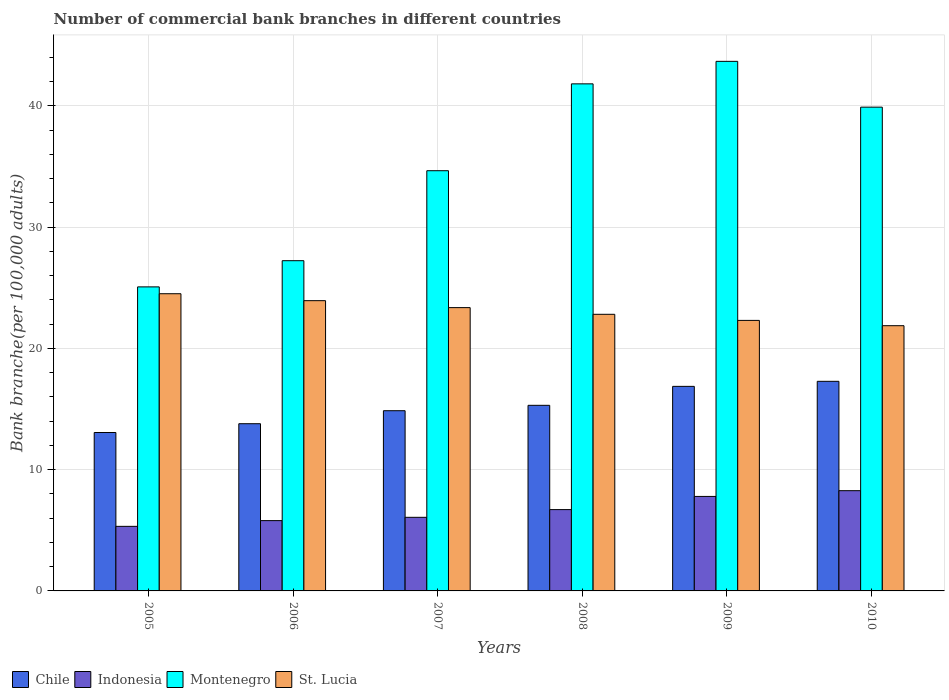How many different coloured bars are there?
Your response must be concise. 4. How many groups of bars are there?
Keep it short and to the point. 6. Are the number of bars on each tick of the X-axis equal?
Ensure brevity in your answer.  Yes. How many bars are there on the 3rd tick from the right?
Ensure brevity in your answer.  4. In how many cases, is the number of bars for a given year not equal to the number of legend labels?
Ensure brevity in your answer.  0. What is the number of commercial bank branches in St. Lucia in 2005?
Make the answer very short. 24.51. Across all years, what is the maximum number of commercial bank branches in Chile?
Your answer should be very brief. 17.28. Across all years, what is the minimum number of commercial bank branches in Chile?
Provide a short and direct response. 13.06. In which year was the number of commercial bank branches in St. Lucia maximum?
Provide a short and direct response. 2005. What is the total number of commercial bank branches in St. Lucia in the graph?
Ensure brevity in your answer.  138.79. What is the difference between the number of commercial bank branches in Chile in 2005 and that in 2010?
Offer a very short reply. -4.22. What is the difference between the number of commercial bank branches in Chile in 2005 and the number of commercial bank branches in Montenegro in 2009?
Provide a short and direct response. -30.61. What is the average number of commercial bank branches in Indonesia per year?
Your response must be concise. 6.66. In the year 2007, what is the difference between the number of commercial bank branches in Montenegro and number of commercial bank branches in Indonesia?
Give a very brief answer. 28.58. In how many years, is the number of commercial bank branches in Indonesia greater than 24?
Offer a very short reply. 0. What is the ratio of the number of commercial bank branches in Chile in 2005 to that in 2008?
Provide a succinct answer. 0.85. Is the difference between the number of commercial bank branches in Montenegro in 2007 and 2009 greater than the difference between the number of commercial bank branches in Indonesia in 2007 and 2009?
Provide a short and direct response. No. What is the difference between the highest and the second highest number of commercial bank branches in Montenegro?
Your response must be concise. 1.86. What is the difference between the highest and the lowest number of commercial bank branches in Indonesia?
Make the answer very short. 2.94. Is it the case that in every year, the sum of the number of commercial bank branches in Montenegro and number of commercial bank branches in Indonesia is greater than the sum of number of commercial bank branches in St. Lucia and number of commercial bank branches in Chile?
Offer a very short reply. Yes. What does the 1st bar from the right in 2009 represents?
Offer a very short reply. St. Lucia. Is it the case that in every year, the sum of the number of commercial bank branches in Indonesia and number of commercial bank branches in Chile is greater than the number of commercial bank branches in Montenegro?
Your response must be concise. No. How many bars are there?
Offer a terse response. 24. Does the graph contain any zero values?
Keep it short and to the point. No. What is the title of the graph?
Make the answer very short. Number of commercial bank branches in different countries. Does "Upper middle income" appear as one of the legend labels in the graph?
Provide a succinct answer. No. What is the label or title of the Y-axis?
Offer a very short reply. Bank branche(per 100,0 adults). What is the Bank branche(per 100,000 adults) of Chile in 2005?
Ensure brevity in your answer.  13.06. What is the Bank branche(per 100,000 adults) in Indonesia in 2005?
Provide a succinct answer. 5.32. What is the Bank branche(per 100,000 adults) in Montenegro in 2005?
Your answer should be very brief. 25.07. What is the Bank branche(per 100,000 adults) of St. Lucia in 2005?
Ensure brevity in your answer.  24.51. What is the Bank branche(per 100,000 adults) in Chile in 2006?
Your answer should be compact. 13.79. What is the Bank branche(per 100,000 adults) in Indonesia in 2006?
Give a very brief answer. 5.8. What is the Bank branche(per 100,000 adults) in Montenegro in 2006?
Your response must be concise. 27.23. What is the Bank branche(per 100,000 adults) of St. Lucia in 2006?
Provide a short and direct response. 23.93. What is the Bank branche(per 100,000 adults) of Chile in 2007?
Ensure brevity in your answer.  14.86. What is the Bank branche(per 100,000 adults) in Indonesia in 2007?
Offer a terse response. 6.07. What is the Bank branche(per 100,000 adults) in Montenegro in 2007?
Keep it short and to the point. 34.65. What is the Bank branche(per 100,000 adults) of St. Lucia in 2007?
Offer a terse response. 23.36. What is the Bank branche(per 100,000 adults) in Chile in 2008?
Offer a very short reply. 15.3. What is the Bank branche(per 100,000 adults) of Indonesia in 2008?
Offer a very short reply. 6.71. What is the Bank branche(per 100,000 adults) in Montenegro in 2008?
Give a very brief answer. 41.81. What is the Bank branche(per 100,000 adults) in St. Lucia in 2008?
Ensure brevity in your answer.  22.81. What is the Bank branche(per 100,000 adults) in Chile in 2009?
Your response must be concise. 16.87. What is the Bank branche(per 100,000 adults) of Indonesia in 2009?
Make the answer very short. 7.79. What is the Bank branche(per 100,000 adults) in Montenegro in 2009?
Keep it short and to the point. 43.67. What is the Bank branche(per 100,000 adults) in St. Lucia in 2009?
Offer a terse response. 22.31. What is the Bank branche(per 100,000 adults) in Chile in 2010?
Provide a succinct answer. 17.28. What is the Bank branche(per 100,000 adults) of Indonesia in 2010?
Provide a succinct answer. 8.27. What is the Bank branche(per 100,000 adults) of Montenegro in 2010?
Give a very brief answer. 39.89. What is the Bank branche(per 100,000 adults) in St. Lucia in 2010?
Your answer should be very brief. 21.87. Across all years, what is the maximum Bank branche(per 100,000 adults) in Chile?
Your answer should be very brief. 17.28. Across all years, what is the maximum Bank branche(per 100,000 adults) in Indonesia?
Ensure brevity in your answer.  8.27. Across all years, what is the maximum Bank branche(per 100,000 adults) of Montenegro?
Offer a terse response. 43.67. Across all years, what is the maximum Bank branche(per 100,000 adults) of St. Lucia?
Your answer should be very brief. 24.51. Across all years, what is the minimum Bank branche(per 100,000 adults) in Chile?
Your response must be concise. 13.06. Across all years, what is the minimum Bank branche(per 100,000 adults) in Indonesia?
Give a very brief answer. 5.32. Across all years, what is the minimum Bank branche(per 100,000 adults) of Montenegro?
Offer a terse response. 25.07. Across all years, what is the minimum Bank branche(per 100,000 adults) of St. Lucia?
Give a very brief answer. 21.87. What is the total Bank branche(per 100,000 adults) in Chile in the graph?
Your response must be concise. 91.16. What is the total Bank branche(per 100,000 adults) of Indonesia in the graph?
Provide a short and direct response. 39.95. What is the total Bank branche(per 100,000 adults) in Montenegro in the graph?
Your answer should be very brief. 212.32. What is the total Bank branche(per 100,000 adults) in St. Lucia in the graph?
Provide a short and direct response. 138.79. What is the difference between the Bank branche(per 100,000 adults) of Chile in 2005 and that in 2006?
Offer a terse response. -0.73. What is the difference between the Bank branche(per 100,000 adults) of Indonesia in 2005 and that in 2006?
Your answer should be compact. -0.47. What is the difference between the Bank branche(per 100,000 adults) in Montenegro in 2005 and that in 2006?
Keep it short and to the point. -2.16. What is the difference between the Bank branche(per 100,000 adults) in St. Lucia in 2005 and that in 2006?
Offer a very short reply. 0.57. What is the difference between the Bank branche(per 100,000 adults) of Chile in 2005 and that in 2007?
Provide a succinct answer. -1.8. What is the difference between the Bank branche(per 100,000 adults) of Indonesia in 2005 and that in 2007?
Offer a very short reply. -0.74. What is the difference between the Bank branche(per 100,000 adults) of Montenegro in 2005 and that in 2007?
Offer a terse response. -9.58. What is the difference between the Bank branche(per 100,000 adults) of St. Lucia in 2005 and that in 2007?
Your answer should be compact. 1.15. What is the difference between the Bank branche(per 100,000 adults) in Chile in 2005 and that in 2008?
Offer a terse response. -2.24. What is the difference between the Bank branche(per 100,000 adults) in Indonesia in 2005 and that in 2008?
Your answer should be compact. -1.38. What is the difference between the Bank branche(per 100,000 adults) in Montenegro in 2005 and that in 2008?
Offer a very short reply. -16.74. What is the difference between the Bank branche(per 100,000 adults) in St. Lucia in 2005 and that in 2008?
Keep it short and to the point. 1.7. What is the difference between the Bank branche(per 100,000 adults) of Chile in 2005 and that in 2009?
Ensure brevity in your answer.  -3.8. What is the difference between the Bank branche(per 100,000 adults) in Indonesia in 2005 and that in 2009?
Your response must be concise. -2.47. What is the difference between the Bank branche(per 100,000 adults) in Montenegro in 2005 and that in 2009?
Offer a very short reply. -18.6. What is the difference between the Bank branche(per 100,000 adults) of St. Lucia in 2005 and that in 2009?
Give a very brief answer. 2.2. What is the difference between the Bank branche(per 100,000 adults) in Chile in 2005 and that in 2010?
Your response must be concise. -4.22. What is the difference between the Bank branche(per 100,000 adults) in Indonesia in 2005 and that in 2010?
Keep it short and to the point. -2.94. What is the difference between the Bank branche(per 100,000 adults) of Montenegro in 2005 and that in 2010?
Your answer should be compact. -14.82. What is the difference between the Bank branche(per 100,000 adults) in St. Lucia in 2005 and that in 2010?
Your response must be concise. 2.64. What is the difference between the Bank branche(per 100,000 adults) in Chile in 2006 and that in 2007?
Provide a short and direct response. -1.07. What is the difference between the Bank branche(per 100,000 adults) of Indonesia in 2006 and that in 2007?
Your answer should be compact. -0.27. What is the difference between the Bank branche(per 100,000 adults) of Montenegro in 2006 and that in 2007?
Keep it short and to the point. -7.42. What is the difference between the Bank branche(per 100,000 adults) in St. Lucia in 2006 and that in 2007?
Provide a short and direct response. 0.57. What is the difference between the Bank branche(per 100,000 adults) in Chile in 2006 and that in 2008?
Make the answer very short. -1.52. What is the difference between the Bank branche(per 100,000 adults) of Indonesia in 2006 and that in 2008?
Keep it short and to the point. -0.91. What is the difference between the Bank branche(per 100,000 adults) of Montenegro in 2006 and that in 2008?
Your response must be concise. -14.58. What is the difference between the Bank branche(per 100,000 adults) in St. Lucia in 2006 and that in 2008?
Make the answer very short. 1.12. What is the difference between the Bank branche(per 100,000 adults) in Chile in 2006 and that in 2009?
Provide a succinct answer. -3.08. What is the difference between the Bank branche(per 100,000 adults) of Indonesia in 2006 and that in 2009?
Your response must be concise. -1.99. What is the difference between the Bank branche(per 100,000 adults) of Montenegro in 2006 and that in 2009?
Provide a short and direct response. -16.44. What is the difference between the Bank branche(per 100,000 adults) in St. Lucia in 2006 and that in 2009?
Your answer should be very brief. 1.63. What is the difference between the Bank branche(per 100,000 adults) in Chile in 2006 and that in 2010?
Your answer should be compact. -3.5. What is the difference between the Bank branche(per 100,000 adults) in Indonesia in 2006 and that in 2010?
Your answer should be very brief. -2.47. What is the difference between the Bank branche(per 100,000 adults) of Montenegro in 2006 and that in 2010?
Provide a short and direct response. -12.66. What is the difference between the Bank branche(per 100,000 adults) of St. Lucia in 2006 and that in 2010?
Offer a very short reply. 2.06. What is the difference between the Bank branche(per 100,000 adults) in Chile in 2007 and that in 2008?
Offer a very short reply. -0.44. What is the difference between the Bank branche(per 100,000 adults) in Indonesia in 2007 and that in 2008?
Provide a short and direct response. -0.64. What is the difference between the Bank branche(per 100,000 adults) of Montenegro in 2007 and that in 2008?
Offer a terse response. -7.16. What is the difference between the Bank branche(per 100,000 adults) in St. Lucia in 2007 and that in 2008?
Provide a short and direct response. 0.55. What is the difference between the Bank branche(per 100,000 adults) of Chile in 2007 and that in 2009?
Make the answer very short. -2.01. What is the difference between the Bank branche(per 100,000 adults) in Indonesia in 2007 and that in 2009?
Provide a succinct answer. -1.72. What is the difference between the Bank branche(per 100,000 adults) of Montenegro in 2007 and that in 2009?
Offer a very short reply. -9.02. What is the difference between the Bank branche(per 100,000 adults) of St. Lucia in 2007 and that in 2009?
Offer a very short reply. 1.05. What is the difference between the Bank branche(per 100,000 adults) in Chile in 2007 and that in 2010?
Make the answer very short. -2.42. What is the difference between the Bank branche(per 100,000 adults) in Indonesia in 2007 and that in 2010?
Your answer should be very brief. -2.2. What is the difference between the Bank branche(per 100,000 adults) in Montenegro in 2007 and that in 2010?
Ensure brevity in your answer.  -5.24. What is the difference between the Bank branche(per 100,000 adults) in St. Lucia in 2007 and that in 2010?
Give a very brief answer. 1.49. What is the difference between the Bank branche(per 100,000 adults) of Chile in 2008 and that in 2009?
Your response must be concise. -1.56. What is the difference between the Bank branche(per 100,000 adults) of Indonesia in 2008 and that in 2009?
Ensure brevity in your answer.  -1.09. What is the difference between the Bank branche(per 100,000 adults) in Montenegro in 2008 and that in 2009?
Make the answer very short. -1.86. What is the difference between the Bank branche(per 100,000 adults) in St. Lucia in 2008 and that in 2009?
Offer a very short reply. 0.5. What is the difference between the Bank branche(per 100,000 adults) in Chile in 2008 and that in 2010?
Make the answer very short. -1.98. What is the difference between the Bank branche(per 100,000 adults) of Indonesia in 2008 and that in 2010?
Your answer should be very brief. -1.56. What is the difference between the Bank branche(per 100,000 adults) of Montenegro in 2008 and that in 2010?
Make the answer very short. 1.92. What is the difference between the Bank branche(per 100,000 adults) in St. Lucia in 2008 and that in 2010?
Give a very brief answer. 0.94. What is the difference between the Bank branche(per 100,000 adults) of Chile in 2009 and that in 2010?
Ensure brevity in your answer.  -0.42. What is the difference between the Bank branche(per 100,000 adults) in Indonesia in 2009 and that in 2010?
Your answer should be very brief. -0.47. What is the difference between the Bank branche(per 100,000 adults) in Montenegro in 2009 and that in 2010?
Offer a terse response. 3.78. What is the difference between the Bank branche(per 100,000 adults) of St. Lucia in 2009 and that in 2010?
Provide a short and direct response. 0.44. What is the difference between the Bank branche(per 100,000 adults) of Chile in 2005 and the Bank branche(per 100,000 adults) of Indonesia in 2006?
Your answer should be very brief. 7.27. What is the difference between the Bank branche(per 100,000 adults) in Chile in 2005 and the Bank branche(per 100,000 adults) in Montenegro in 2006?
Make the answer very short. -14.17. What is the difference between the Bank branche(per 100,000 adults) in Chile in 2005 and the Bank branche(per 100,000 adults) in St. Lucia in 2006?
Offer a terse response. -10.87. What is the difference between the Bank branche(per 100,000 adults) in Indonesia in 2005 and the Bank branche(per 100,000 adults) in Montenegro in 2006?
Provide a succinct answer. -21.91. What is the difference between the Bank branche(per 100,000 adults) in Indonesia in 2005 and the Bank branche(per 100,000 adults) in St. Lucia in 2006?
Provide a succinct answer. -18.61. What is the difference between the Bank branche(per 100,000 adults) of Montenegro in 2005 and the Bank branche(per 100,000 adults) of St. Lucia in 2006?
Your response must be concise. 1.14. What is the difference between the Bank branche(per 100,000 adults) of Chile in 2005 and the Bank branche(per 100,000 adults) of Indonesia in 2007?
Provide a succinct answer. 6.99. What is the difference between the Bank branche(per 100,000 adults) in Chile in 2005 and the Bank branche(per 100,000 adults) in Montenegro in 2007?
Your response must be concise. -21.59. What is the difference between the Bank branche(per 100,000 adults) in Chile in 2005 and the Bank branche(per 100,000 adults) in St. Lucia in 2007?
Your answer should be compact. -10.3. What is the difference between the Bank branche(per 100,000 adults) in Indonesia in 2005 and the Bank branche(per 100,000 adults) in Montenegro in 2007?
Provide a succinct answer. -29.32. What is the difference between the Bank branche(per 100,000 adults) of Indonesia in 2005 and the Bank branche(per 100,000 adults) of St. Lucia in 2007?
Your answer should be very brief. -18.04. What is the difference between the Bank branche(per 100,000 adults) in Montenegro in 2005 and the Bank branche(per 100,000 adults) in St. Lucia in 2007?
Offer a terse response. 1.71. What is the difference between the Bank branche(per 100,000 adults) in Chile in 2005 and the Bank branche(per 100,000 adults) in Indonesia in 2008?
Give a very brief answer. 6.36. What is the difference between the Bank branche(per 100,000 adults) of Chile in 2005 and the Bank branche(per 100,000 adults) of Montenegro in 2008?
Keep it short and to the point. -28.75. What is the difference between the Bank branche(per 100,000 adults) of Chile in 2005 and the Bank branche(per 100,000 adults) of St. Lucia in 2008?
Make the answer very short. -9.75. What is the difference between the Bank branche(per 100,000 adults) in Indonesia in 2005 and the Bank branche(per 100,000 adults) in Montenegro in 2008?
Ensure brevity in your answer.  -36.49. What is the difference between the Bank branche(per 100,000 adults) of Indonesia in 2005 and the Bank branche(per 100,000 adults) of St. Lucia in 2008?
Offer a very short reply. -17.48. What is the difference between the Bank branche(per 100,000 adults) in Montenegro in 2005 and the Bank branche(per 100,000 adults) in St. Lucia in 2008?
Offer a terse response. 2.26. What is the difference between the Bank branche(per 100,000 adults) in Chile in 2005 and the Bank branche(per 100,000 adults) in Indonesia in 2009?
Your response must be concise. 5.27. What is the difference between the Bank branche(per 100,000 adults) in Chile in 2005 and the Bank branche(per 100,000 adults) in Montenegro in 2009?
Make the answer very short. -30.61. What is the difference between the Bank branche(per 100,000 adults) of Chile in 2005 and the Bank branche(per 100,000 adults) of St. Lucia in 2009?
Keep it short and to the point. -9.25. What is the difference between the Bank branche(per 100,000 adults) in Indonesia in 2005 and the Bank branche(per 100,000 adults) in Montenegro in 2009?
Provide a succinct answer. -38.34. What is the difference between the Bank branche(per 100,000 adults) of Indonesia in 2005 and the Bank branche(per 100,000 adults) of St. Lucia in 2009?
Your answer should be compact. -16.98. What is the difference between the Bank branche(per 100,000 adults) of Montenegro in 2005 and the Bank branche(per 100,000 adults) of St. Lucia in 2009?
Your answer should be very brief. 2.76. What is the difference between the Bank branche(per 100,000 adults) of Chile in 2005 and the Bank branche(per 100,000 adults) of Indonesia in 2010?
Offer a very short reply. 4.8. What is the difference between the Bank branche(per 100,000 adults) in Chile in 2005 and the Bank branche(per 100,000 adults) in Montenegro in 2010?
Your answer should be compact. -26.83. What is the difference between the Bank branche(per 100,000 adults) of Chile in 2005 and the Bank branche(per 100,000 adults) of St. Lucia in 2010?
Keep it short and to the point. -8.81. What is the difference between the Bank branche(per 100,000 adults) in Indonesia in 2005 and the Bank branche(per 100,000 adults) in Montenegro in 2010?
Your response must be concise. -34.57. What is the difference between the Bank branche(per 100,000 adults) of Indonesia in 2005 and the Bank branche(per 100,000 adults) of St. Lucia in 2010?
Ensure brevity in your answer.  -16.55. What is the difference between the Bank branche(per 100,000 adults) in Montenegro in 2005 and the Bank branche(per 100,000 adults) in St. Lucia in 2010?
Make the answer very short. 3.2. What is the difference between the Bank branche(per 100,000 adults) of Chile in 2006 and the Bank branche(per 100,000 adults) of Indonesia in 2007?
Provide a short and direct response. 7.72. What is the difference between the Bank branche(per 100,000 adults) in Chile in 2006 and the Bank branche(per 100,000 adults) in Montenegro in 2007?
Ensure brevity in your answer.  -20.86. What is the difference between the Bank branche(per 100,000 adults) in Chile in 2006 and the Bank branche(per 100,000 adults) in St. Lucia in 2007?
Provide a succinct answer. -9.57. What is the difference between the Bank branche(per 100,000 adults) of Indonesia in 2006 and the Bank branche(per 100,000 adults) of Montenegro in 2007?
Your answer should be very brief. -28.85. What is the difference between the Bank branche(per 100,000 adults) of Indonesia in 2006 and the Bank branche(per 100,000 adults) of St. Lucia in 2007?
Your answer should be compact. -17.56. What is the difference between the Bank branche(per 100,000 adults) of Montenegro in 2006 and the Bank branche(per 100,000 adults) of St. Lucia in 2007?
Give a very brief answer. 3.87. What is the difference between the Bank branche(per 100,000 adults) in Chile in 2006 and the Bank branche(per 100,000 adults) in Indonesia in 2008?
Keep it short and to the point. 7.08. What is the difference between the Bank branche(per 100,000 adults) in Chile in 2006 and the Bank branche(per 100,000 adults) in Montenegro in 2008?
Give a very brief answer. -28.02. What is the difference between the Bank branche(per 100,000 adults) in Chile in 2006 and the Bank branche(per 100,000 adults) in St. Lucia in 2008?
Provide a succinct answer. -9.02. What is the difference between the Bank branche(per 100,000 adults) of Indonesia in 2006 and the Bank branche(per 100,000 adults) of Montenegro in 2008?
Offer a very short reply. -36.01. What is the difference between the Bank branche(per 100,000 adults) of Indonesia in 2006 and the Bank branche(per 100,000 adults) of St. Lucia in 2008?
Provide a succinct answer. -17.01. What is the difference between the Bank branche(per 100,000 adults) in Montenegro in 2006 and the Bank branche(per 100,000 adults) in St. Lucia in 2008?
Make the answer very short. 4.42. What is the difference between the Bank branche(per 100,000 adults) of Chile in 2006 and the Bank branche(per 100,000 adults) of Indonesia in 2009?
Your response must be concise. 6. What is the difference between the Bank branche(per 100,000 adults) of Chile in 2006 and the Bank branche(per 100,000 adults) of Montenegro in 2009?
Keep it short and to the point. -29.88. What is the difference between the Bank branche(per 100,000 adults) of Chile in 2006 and the Bank branche(per 100,000 adults) of St. Lucia in 2009?
Keep it short and to the point. -8.52. What is the difference between the Bank branche(per 100,000 adults) in Indonesia in 2006 and the Bank branche(per 100,000 adults) in Montenegro in 2009?
Offer a terse response. -37.87. What is the difference between the Bank branche(per 100,000 adults) in Indonesia in 2006 and the Bank branche(per 100,000 adults) in St. Lucia in 2009?
Your answer should be very brief. -16.51. What is the difference between the Bank branche(per 100,000 adults) of Montenegro in 2006 and the Bank branche(per 100,000 adults) of St. Lucia in 2009?
Make the answer very short. 4.92. What is the difference between the Bank branche(per 100,000 adults) of Chile in 2006 and the Bank branche(per 100,000 adults) of Indonesia in 2010?
Your response must be concise. 5.52. What is the difference between the Bank branche(per 100,000 adults) of Chile in 2006 and the Bank branche(per 100,000 adults) of Montenegro in 2010?
Your answer should be very brief. -26.1. What is the difference between the Bank branche(per 100,000 adults) in Chile in 2006 and the Bank branche(per 100,000 adults) in St. Lucia in 2010?
Your answer should be compact. -8.08. What is the difference between the Bank branche(per 100,000 adults) of Indonesia in 2006 and the Bank branche(per 100,000 adults) of Montenegro in 2010?
Give a very brief answer. -34.09. What is the difference between the Bank branche(per 100,000 adults) of Indonesia in 2006 and the Bank branche(per 100,000 adults) of St. Lucia in 2010?
Make the answer very short. -16.07. What is the difference between the Bank branche(per 100,000 adults) of Montenegro in 2006 and the Bank branche(per 100,000 adults) of St. Lucia in 2010?
Ensure brevity in your answer.  5.36. What is the difference between the Bank branche(per 100,000 adults) of Chile in 2007 and the Bank branche(per 100,000 adults) of Indonesia in 2008?
Provide a succinct answer. 8.15. What is the difference between the Bank branche(per 100,000 adults) in Chile in 2007 and the Bank branche(per 100,000 adults) in Montenegro in 2008?
Keep it short and to the point. -26.95. What is the difference between the Bank branche(per 100,000 adults) of Chile in 2007 and the Bank branche(per 100,000 adults) of St. Lucia in 2008?
Give a very brief answer. -7.95. What is the difference between the Bank branche(per 100,000 adults) of Indonesia in 2007 and the Bank branche(per 100,000 adults) of Montenegro in 2008?
Your response must be concise. -35.74. What is the difference between the Bank branche(per 100,000 adults) of Indonesia in 2007 and the Bank branche(per 100,000 adults) of St. Lucia in 2008?
Offer a very short reply. -16.74. What is the difference between the Bank branche(per 100,000 adults) of Montenegro in 2007 and the Bank branche(per 100,000 adults) of St. Lucia in 2008?
Provide a succinct answer. 11.84. What is the difference between the Bank branche(per 100,000 adults) in Chile in 2007 and the Bank branche(per 100,000 adults) in Indonesia in 2009?
Make the answer very short. 7.07. What is the difference between the Bank branche(per 100,000 adults) of Chile in 2007 and the Bank branche(per 100,000 adults) of Montenegro in 2009?
Your answer should be very brief. -28.81. What is the difference between the Bank branche(per 100,000 adults) of Chile in 2007 and the Bank branche(per 100,000 adults) of St. Lucia in 2009?
Offer a terse response. -7.45. What is the difference between the Bank branche(per 100,000 adults) in Indonesia in 2007 and the Bank branche(per 100,000 adults) in Montenegro in 2009?
Your answer should be very brief. -37.6. What is the difference between the Bank branche(per 100,000 adults) of Indonesia in 2007 and the Bank branche(per 100,000 adults) of St. Lucia in 2009?
Offer a terse response. -16.24. What is the difference between the Bank branche(per 100,000 adults) of Montenegro in 2007 and the Bank branche(per 100,000 adults) of St. Lucia in 2009?
Provide a short and direct response. 12.34. What is the difference between the Bank branche(per 100,000 adults) in Chile in 2007 and the Bank branche(per 100,000 adults) in Indonesia in 2010?
Offer a terse response. 6.59. What is the difference between the Bank branche(per 100,000 adults) of Chile in 2007 and the Bank branche(per 100,000 adults) of Montenegro in 2010?
Ensure brevity in your answer.  -25.03. What is the difference between the Bank branche(per 100,000 adults) of Chile in 2007 and the Bank branche(per 100,000 adults) of St. Lucia in 2010?
Ensure brevity in your answer.  -7.01. What is the difference between the Bank branche(per 100,000 adults) of Indonesia in 2007 and the Bank branche(per 100,000 adults) of Montenegro in 2010?
Ensure brevity in your answer.  -33.82. What is the difference between the Bank branche(per 100,000 adults) in Indonesia in 2007 and the Bank branche(per 100,000 adults) in St. Lucia in 2010?
Offer a very short reply. -15.8. What is the difference between the Bank branche(per 100,000 adults) in Montenegro in 2007 and the Bank branche(per 100,000 adults) in St. Lucia in 2010?
Your answer should be very brief. 12.78. What is the difference between the Bank branche(per 100,000 adults) of Chile in 2008 and the Bank branche(per 100,000 adults) of Indonesia in 2009?
Give a very brief answer. 7.51. What is the difference between the Bank branche(per 100,000 adults) in Chile in 2008 and the Bank branche(per 100,000 adults) in Montenegro in 2009?
Offer a very short reply. -28.36. What is the difference between the Bank branche(per 100,000 adults) in Chile in 2008 and the Bank branche(per 100,000 adults) in St. Lucia in 2009?
Your answer should be very brief. -7. What is the difference between the Bank branche(per 100,000 adults) of Indonesia in 2008 and the Bank branche(per 100,000 adults) of Montenegro in 2009?
Ensure brevity in your answer.  -36.96. What is the difference between the Bank branche(per 100,000 adults) in Indonesia in 2008 and the Bank branche(per 100,000 adults) in St. Lucia in 2009?
Give a very brief answer. -15.6. What is the difference between the Bank branche(per 100,000 adults) in Montenegro in 2008 and the Bank branche(per 100,000 adults) in St. Lucia in 2009?
Provide a short and direct response. 19.5. What is the difference between the Bank branche(per 100,000 adults) in Chile in 2008 and the Bank branche(per 100,000 adults) in Indonesia in 2010?
Your response must be concise. 7.04. What is the difference between the Bank branche(per 100,000 adults) in Chile in 2008 and the Bank branche(per 100,000 adults) in Montenegro in 2010?
Ensure brevity in your answer.  -24.59. What is the difference between the Bank branche(per 100,000 adults) of Chile in 2008 and the Bank branche(per 100,000 adults) of St. Lucia in 2010?
Provide a succinct answer. -6.57. What is the difference between the Bank branche(per 100,000 adults) of Indonesia in 2008 and the Bank branche(per 100,000 adults) of Montenegro in 2010?
Offer a very short reply. -33.19. What is the difference between the Bank branche(per 100,000 adults) of Indonesia in 2008 and the Bank branche(per 100,000 adults) of St. Lucia in 2010?
Keep it short and to the point. -15.16. What is the difference between the Bank branche(per 100,000 adults) of Montenegro in 2008 and the Bank branche(per 100,000 adults) of St. Lucia in 2010?
Offer a very short reply. 19.94. What is the difference between the Bank branche(per 100,000 adults) in Chile in 2009 and the Bank branche(per 100,000 adults) in Indonesia in 2010?
Offer a very short reply. 8.6. What is the difference between the Bank branche(per 100,000 adults) of Chile in 2009 and the Bank branche(per 100,000 adults) of Montenegro in 2010?
Your answer should be very brief. -23.02. What is the difference between the Bank branche(per 100,000 adults) of Chile in 2009 and the Bank branche(per 100,000 adults) of St. Lucia in 2010?
Your answer should be very brief. -5. What is the difference between the Bank branche(per 100,000 adults) in Indonesia in 2009 and the Bank branche(per 100,000 adults) in Montenegro in 2010?
Keep it short and to the point. -32.1. What is the difference between the Bank branche(per 100,000 adults) of Indonesia in 2009 and the Bank branche(per 100,000 adults) of St. Lucia in 2010?
Provide a succinct answer. -14.08. What is the difference between the Bank branche(per 100,000 adults) in Montenegro in 2009 and the Bank branche(per 100,000 adults) in St. Lucia in 2010?
Keep it short and to the point. 21.8. What is the average Bank branche(per 100,000 adults) in Chile per year?
Your response must be concise. 15.19. What is the average Bank branche(per 100,000 adults) of Indonesia per year?
Your answer should be compact. 6.66. What is the average Bank branche(per 100,000 adults) of Montenegro per year?
Offer a very short reply. 35.39. What is the average Bank branche(per 100,000 adults) in St. Lucia per year?
Ensure brevity in your answer.  23.13. In the year 2005, what is the difference between the Bank branche(per 100,000 adults) of Chile and Bank branche(per 100,000 adults) of Indonesia?
Offer a very short reply. 7.74. In the year 2005, what is the difference between the Bank branche(per 100,000 adults) of Chile and Bank branche(per 100,000 adults) of Montenegro?
Offer a terse response. -12.01. In the year 2005, what is the difference between the Bank branche(per 100,000 adults) of Chile and Bank branche(per 100,000 adults) of St. Lucia?
Make the answer very short. -11.44. In the year 2005, what is the difference between the Bank branche(per 100,000 adults) of Indonesia and Bank branche(per 100,000 adults) of Montenegro?
Your response must be concise. -19.75. In the year 2005, what is the difference between the Bank branche(per 100,000 adults) in Indonesia and Bank branche(per 100,000 adults) in St. Lucia?
Offer a terse response. -19.18. In the year 2005, what is the difference between the Bank branche(per 100,000 adults) in Montenegro and Bank branche(per 100,000 adults) in St. Lucia?
Ensure brevity in your answer.  0.56. In the year 2006, what is the difference between the Bank branche(per 100,000 adults) in Chile and Bank branche(per 100,000 adults) in Indonesia?
Your answer should be compact. 7.99. In the year 2006, what is the difference between the Bank branche(per 100,000 adults) in Chile and Bank branche(per 100,000 adults) in Montenegro?
Give a very brief answer. -13.44. In the year 2006, what is the difference between the Bank branche(per 100,000 adults) in Chile and Bank branche(per 100,000 adults) in St. Lucia?
Make the answer very short. -10.15. In the year 2006, what is the difference between the Bank branche(per 100,000 adults) of Indonesia and Bank branche(per 100,000 adults) of Montenegro?
Keep it short and to the point. -21.43. In the year 2006, what is the difference between the Bank branche(per 100,000 adults) of Indonesia and Bank branche(per 100,000 adults) of St. Lucia?
Keep it short and to the point. -18.14. In the year 2006, what is the difference between the Bank branche(per 100,000 adults) in Montenegro and Bank branche(per 100,000 adults) in St. Lucia?
Offer a very short reply. 3.3. In the year 2007, what is the difference between the Bank branche(per 100,000 adults) of Chile and Bank branche(per 100,000 adults) of Indonesia?
Ensure brevity in your answer.  8.79. In the year 2007, what is the difference between the Bank branche(per 100,000 adults) in Chile and Bank branche(per 100,000 adults) in Montenegro?
Offer a terse response. -19.79. In the year 2007, what is the difference between the Bank branche(per 100,000 adults) in Chile and Bank branche(per 100,000 adults) in St. Lucia?
Offer a very short reply. -8.5. In the year 2007, what is the difference between the Bank branche(per 100,000 adults) in Indonesia and Bank branche(per 100,000 adults) in Montenegro?
Your answer should be compact. -28.58. In the year 2007, what is the difference between the Bank branche(per 100,000 adults) of Indonesia and Bank branche(per 100,000 adults) of St. Lucia?
Offer a very short reply. -17.29. In the year 2007, what is the difference between the Bank branche(per 100,000 adults) in Montenegro and Bank branche(per 100,000 adults) in St. Lucia?
Your answer should be compact. 11.29. In the year 2008, what is the difference between the Bank branche(per 100,000 adults) in Chile and Bank branche(per 100,000 adults) in Indonesia?
Offer a terse response. 8.6. In the year 2008, what is the difference between the Bank branche(per 100,000 adults) of Chile and Bank branche(per 100,000 adults) of Montenegro?
Provide a short and direct response. -26.51. In the year 2008, what is the difference between the Bank branche(per 100,000 adults) of Chile and Bank branche(per 100,000 adults) of St. Lucia?
Ensure brevity in your answer.  -7.51. In the year 2008, what is the difference between the Bank branche(per 100,000 adults) of Indonesia and Bank branche(per 100,000 adults) of Montenegro?
Your answer should be compact. -35.11. In the year 2008, what is the difference between the Bank branche(per 100,000 adults) of Indonesia and Bank branche(per 100,000 adults) of St. Lucia?
Make the answer very short. -16.1. In the year 2008, what is the difference between the Bank branche(per 100,000 adults) of Montenegro and Bank branche(per 100,000 adults) of St. Lucia?
Ensure brevity in your answer.  19. In the year 2009, what is the difference between the Bank branche(per 100,000 adults) in Chile and Bank branche(per 100,000 adults) in Indonesia?
Ensure brevity in your answer.  9.08. In the year 2009, what is the difference between the Bank branche(per 100,000 adults) of Chile and Bank branche(per 100,000 adults) of Montenegro?
Offer a terse response. -26.8. In the year 2009, what is the difference between the Bank branche(per 100,000 adults) of Chile and Bank branche(per 100,000 adults) of St. Lucia?
Keep it short and to the point. -5.44. In the year 2009, what is the difference between the Bank branche(per 100,000 adults) of Indonesia and Bank branche(per 100,000 adults) of Montenegro?
Give a very brief answer. -35.88. In the year 2009, what is the difference between the Bank branche(per 100,000 adults) of Indonesia and Bank branche(per 100,000 adults) of St. Lucia?
Your response must be concise. -14.52. In the year 2009, what is the difference between the Bank branche(per 100,000 adults) in Montenegro and Bank branche(per 100,000 adults) in St. Lucia?
Offer a terse response. 21.36. In the year 2010, what is the difference between the Bank branche(per 100,000 adults) of Chile and Bank branche(per 100,000 adults) of Indonesia?
Provide a short and direct response. 9.02. In the year 2010, what is the difference between the Bank branche(per 100,000 adults) of Chile and Bank branche(per 100,000 adults) of Montenegro?
Provide a short and direct response. -22.61. In the year 2010, what is the difference between the Bank branche(per 100,000 adults) of Chile and Bank branche(per 100,000 adults) of St. Lucia?
Provide a succinct answer. -4.59. In the year 2010, what is the difference between the Bank branche(per 100,000 adults) of Indonesia and Bank branche(per 100,000 adults) of Montenegro?
Make the answer very short. -31.63. In the year 2010, what is the difference between the Bank branche(per 100,000 adults) of Indonesia and Bank branche(per 100,000 adults) of St. Lucia?
Give a very brief answer. -13.61. In the year 2010, what is the difference between the Bank branche(per 100,000 adults) of Montenegro and Bank branche(per 100,000 adults) of St. Lucia?
Give a very brief answer. 18.02. What is the ratio of the Bank branche(per 100,000 adults) in Chile in 2005 to that in 2006?
Your answer should be very brief. 0.95. What is the ratio of the Bank branche(per 100,000 adults) in Indonesia in 2005 to that in 2006?
Provide a succinct answer. 0.92. What is the ratio of the Bank branche(per 100,000 adults) of Montenegro in 2005 to that in 2006?
Provide a short and direct response. 0.92. What is the ratio of the Bank branche(per 100,000 adults) of St. Lucia in 2005 to that in 2006?
Your answer should be very brief. 1.02. What is the ratio of the Bank branche(per 100,000 adults) in Chile in 2005 to that in 2007?
Your answer should be compact. 0.88. What is the ratio of the Bank branche(per 100,000 adults) in Indonesia in 2005 to that in 2007?
Your answer should be very brief. 0.88. What is the ratio of the Bank branche(per 100,000 adults) of Montenegro in 2005 to that in 2007?
Offer a very short reply. 0.72. What is the ratio of the Bank branche(per 100,000 adults) in St. Lucia in 2005 to that in 2007?
Provide a short and direct response. 1.05. What is the ratio of the Bank branche(per 100,000 adults) in Chile in 2005 to that in 2008?
Ensure brevity in your answer.  0.85. What is the ratio of the Bank branche(per 100,000 adults) of Indonesia in 2005 to that in 2008?
Provide a succinct answer. 0.79. What is the ratio of the Bank branche(per 100,000 adults) in Montenegro in 2005 to that in 2008?
Offer a very short reply. 0.6. What is the ratio of the Bank branche(per 100,000 adults) of St. Lucia in 2005 to that in 2008?
Keep it short and to the point. 1.07. What is the ratio of the Bank branche(per 100,000 adults) in Chile in 2005 to that in 2009?
Provide a short and direct response. 0.77. What is the ratio of the Bank branche(per 100,000 adults) of Indonesia in 2005 to that in 2009?
Provide a short and direct response. 0.68. What is the ratio of the Bank branche(per 100,000 adults) of Montenegro in 2005 to that in 2009?
Give a very brief answer. 0.57. What is the ratio of the Bank branche(per 100,000 adults) of St. Lucia in 2005 to that in 2009?
Provide a short and direct response. 1.1. What is the ratio of the Bank branche(per 100,000 adults) of Chile in 2005 to that in 2010?
Ensure brevity in your answer.  0.76. What is the ratio of the Bank branche(per 100,000 adults) of Indonesia in 2005 to that in 2010?
Ensure brevity in your answer.  0.64. What is the ratio of the Bank branche(per 100,000 adults) of Montenegro in 2005 to that in 2010?
Your response must be concise. 0.63. What is the ratio of the Bank branche(per 100,000 adults) of St. Lucia in 2005 to that in 2010?
Your response must be concise. 1.12. What is the ratio of the Bank branche(per 100,000 adults) in Chile in 2006 to that in 2007?
Ensure brevity in your answer.  0.93. What is the ratio of the Bank branche(per 100,000 adults) of Indonesia in 2006 to that in 2007?
Offer a terse response. 0.96. What is the ratio of the Bank branche(per 100,000 adults) of Montenegro in 2006 to that in 2007?
Your answer should be compact. 0.79. What is the ratio of the Bank branche(per 100,000 adults) in St. Lucia in 2006 to that in 2007?
Offer a very short reply. 1.02. What is the ratio of the Bank branche(per 100,000 adults) in Chile in 2006 to that in 2008?
Your response must be concise. 0.9. What is the ratio of the Bank branche(per 100,000 adults) in Indonesia in 2006 to that in 2008?
Your answer should be very brief. 0.86. What is the ratio of the Bank branche(per 100,000 adults) in Montenegro in 2006 to that in 2008?
Your answer should be very brief. 0.65. What is the ratio of the Bank branche(per 100,000 adults) of St. Lucia in 2006 to that in 2008?
Your answer should be compact. 1.05. What is the ratio of the Bank branche(per 100,000 adults) of Chile in 2006 to that in 2009?
Your response must be concise. 0.82. What is the ratio of the Bank branche(per 100,000 adults) of Indonesia in 2006 to that in 2009?
Provide a short and direct response. 0.74. What is the ratio of the Bank branche(per 100,000 adults) of Montenegro in 2006 to that in 2009?
Give a very brief answer. 0.62. What is the ratio of the Bank branche(per 100,000 adults) of St. Lucia in 2006 to that in 2009?
Your answer should be very brief. 1.07. What is the ratio of the Bank branche(per 100,000 adults) in Chile in 2006 to that in 2010?
Offer a very short reply. 0.8. What is the ratio of the Bank branche(per 100,000 adults) in Indonesia in 2006 to that in 2010?
Your answer should be compact. 0.7. What is the ratio of the Bank branche(per 100,000 adults) in Montenegro in 2006 to that in 2010?
Make the answer very short. 0.68. What is the ratio of the Bank branche(per 100,000 adults) of St. Lucia in 2006 to that in 2010?
Give a very brief answer. 1.09. What is the ratio of the Bank branche(per 100,000 adults) in Indonesia in 2007 to that in 2008?
Provide a succinct answer. 0.91. What is the ratio of the Bank branche(per 100,000 adults) in Montenegro in 2007 to that in 2008?
Make the answer very short. 0.83. What is the ratio of the Bank branche(per 100,000 adults) in St. Lucia in 2007 to that in 2008?
Ensure brevity in your answer.  1.02. What is the ratio of the Bank branche(per 100,000 adults) of Chile in 2007 to that in 2009?
Provide a short and direct response. 0.88. What is the ratio of the Bank branche(per 100,000 adults) in Indonesia in 2007 to that in 2009?
Your response must be concise. 0.78. What is the ratio of the Bank branche(per 100,000 adults) in Montenegro in 2007 to that in 2009?
Your answer should be very brief. 0.79. What is the ratio of the Bank branche(per 100,000 adults) of St. Lucia in 2007 to that in 2009?
Your response must be concise. 1.05. What is the ratio of the Bank branche(per 100,000 adults) of Chile in 2007 to that in 2010?
Ensure brevity in your answer.  0.86. What is the ratio of the Bank branche(per 100,000 adults) in Indonesia in 2007 to that in 2010?
Your response must be concise. 0.73. What is the ratio of the Bank branche(per 100,000 adults) of Montenegro in 2007 to that in 2010?
Your response must be concise. 0.87. What is the ratio of the Bank branche(per 100,000 adults) in St. Lucia in 2007 to that in 2010?
Give a very brief answer. 1.07. What is the ratio of the Bank branche(per 100,000 adults) in Chile in 2008 to that in 2009?
Give a very brief answer. 0.91. What is the ratio of the Bank branche(per 100,000 adults) in Indonesia in 2008 to that in 2009?
Your answer should be very brief. 0.86. What is the ratio of the Bank branche(per 100,000 adults) in Montenegro in 2008 to that in 2009?
Ensure brevity in your answer.  0.96. What is the ratio of the Bank branche(per 100,000 adults) of St. Lucia in 2008 to that in 2009?
Ensure brevity in your answer.  1.02. What is the ratio of the Bank branche(per 100,000 adults) of Chile in 2008 to that in 2010?
Give a very brief answer. 0.89. What is the ratio of the Bank branche(per 100,000 adults) of Indonesia in 2008 to that in 2010?
Provide a short and direct response. 0.81. What is the ratio of the Bank branche(per 100,000 adults) of Montenegro in 2008 to that in 2010?
Keep it short and to the point. 1.05. What is the ratio of the Bank branche(per 100,000 adults) of St. Lucia in 2008 to that in 2010?
Give a very brief answer. 1.04. What is the ratio of the Bank branche(per 100,000 adults) of Chile in 2009 to that in 2010?
Keep it short and to the point. 0.98. What is the ratio of the Bank branche(per 100,000 adults) in Indonesia in 2009 to that in 2010?
Offer a very short reply. 0.94. What is the ratio of the Bank branche(per 100,000 adults) in Montenegro in 2009 to that in 2010?
Keep it short and to the point. 1.09. What is the ratio of the Bank branche(per 100,000 adults) in St. Lucia in 2009 to that in 2010?
Keep it short and to the point. 1.02. What is the difference between the highest and the second highest Bank branche(per 100,000 adults) of Chile?
Give a very brief answer. 0.42. What is the difference between the highest and the second highest Bank branche(per 100,000 adults) of Indonesia?
Give a very brief answer. 0.47. What is the difference between the highest and the second highest Bank branche(per 100,000 adults) of Montenegro?
Provide a short and direct response. 1.86. What is the difference between the highest and the second highest Bank branche(per 100,000 adults) in St. Lucia?
Your answer should be very brief. 0.57. What is the difference between the highest and the lowest Bank branche(per 100,000 adults) of Chile?
Provide a succinct answer. 4.22. What is the difference between the highest and the lowest Bank branche(per 100,000 adults) in Indonesia?
Make the answer very short. 2.94. What is the difference between the highest and the lowest Bank branche(per 100,000 adults) of Montenegro?
Make the answer very short. 18.6. What is the difference between the highest and the lowest Bank branche(per 100,000 adults) of St. Lucia?
Your answer should be very brief. 2.64. 